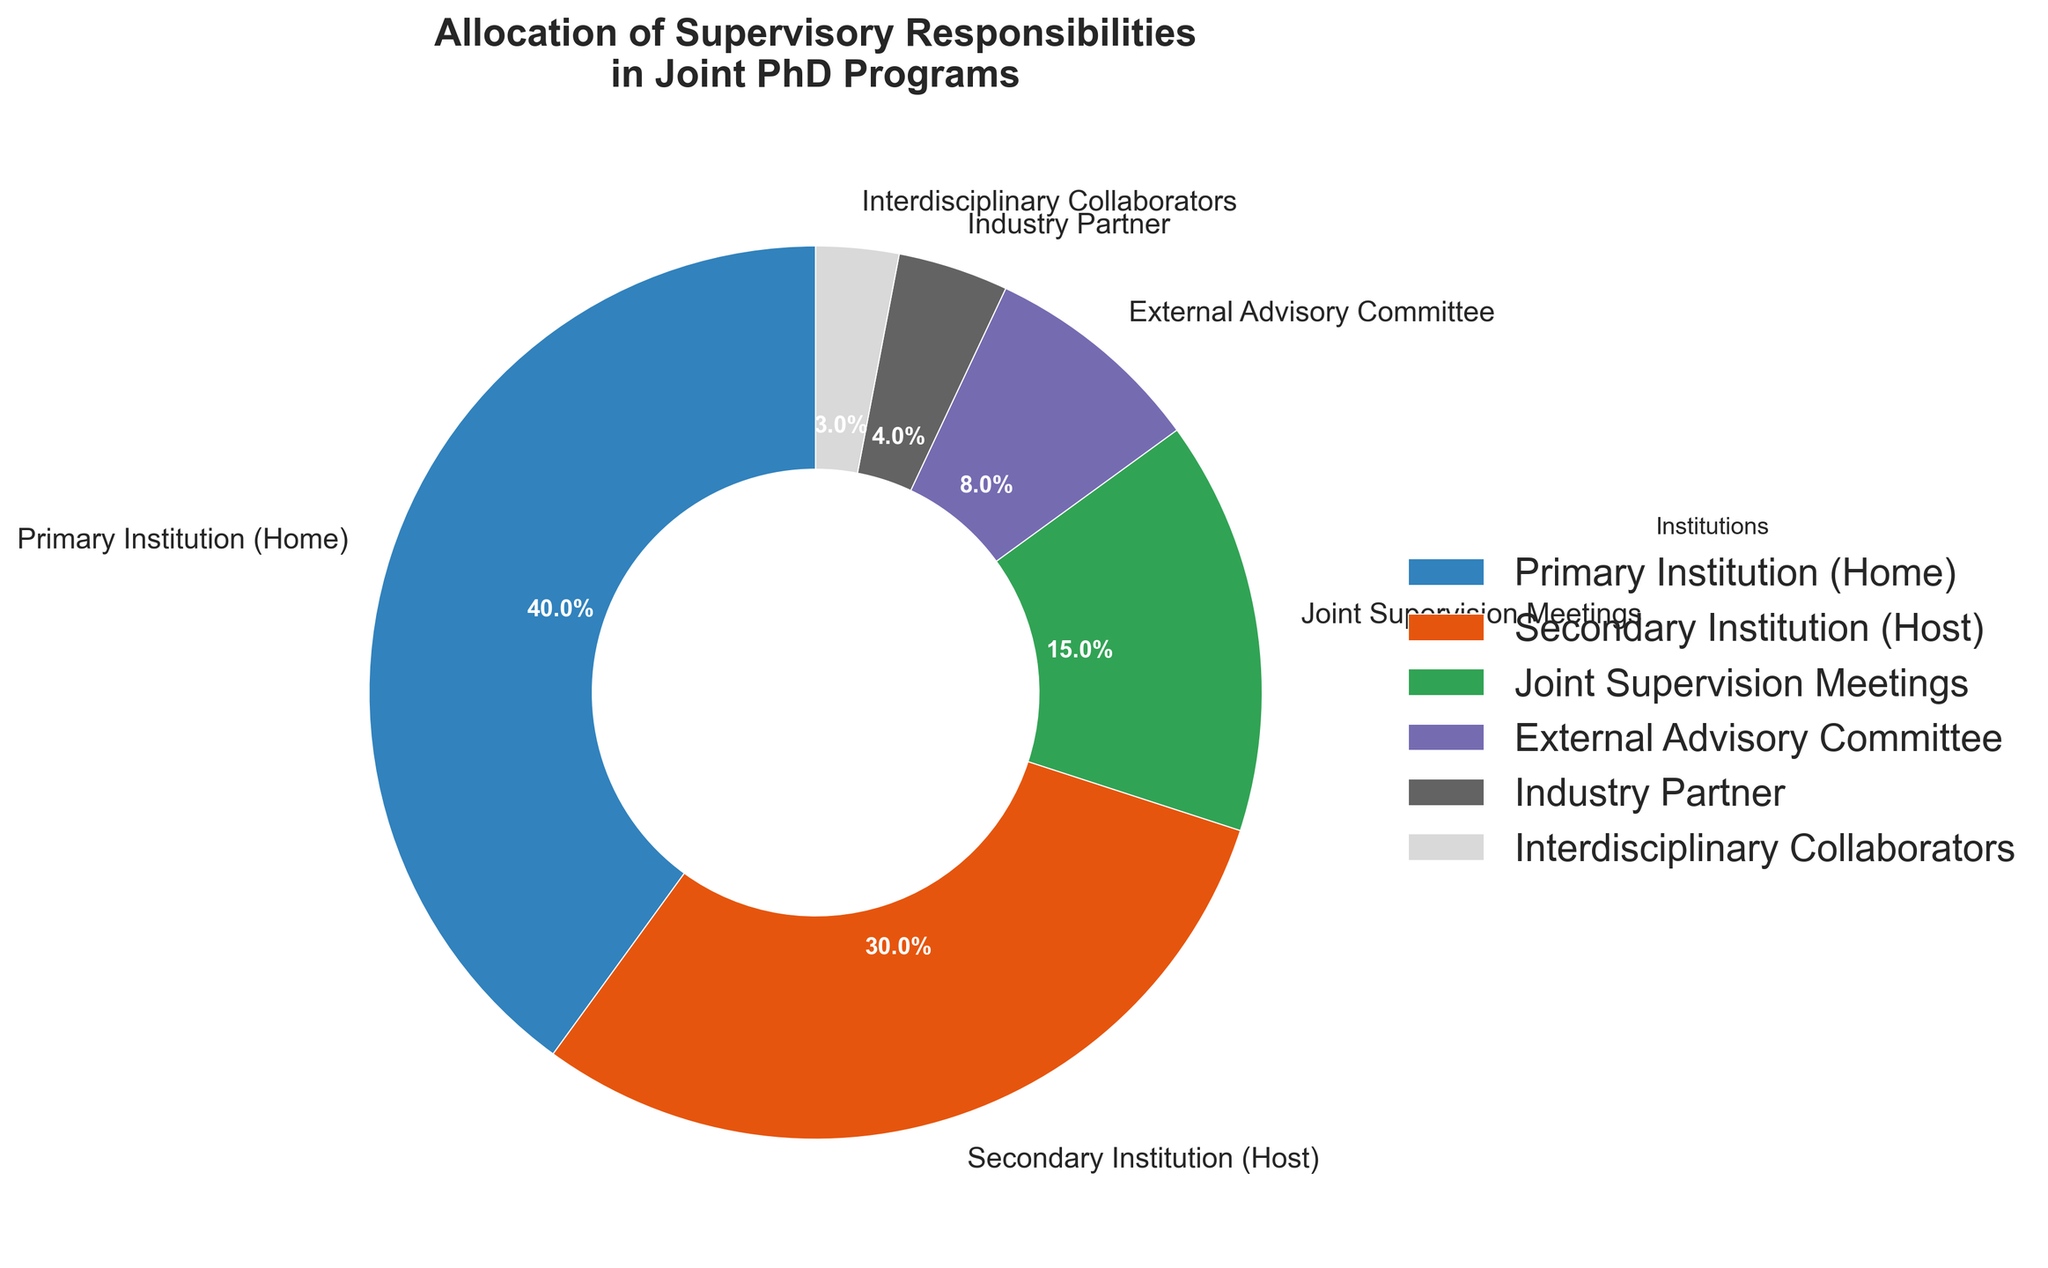What is the total percentage allocated to the Primary Institution (Home) and the Secondary Institution (Host)? Add the percentages for the Primary Institution (Home) and Secondary Institution (Host): 40% + 30% = 70%
Answer: 70% Which institution has the smallest allocation of supervisory responsibilities? Compare the percentages for all institutions: Industry Partner (4%), Interdisciplinary Collaborators (3%), External Advisory Committee (8%), Joint Supervision Meetings (15%), Secondary Institution (Host) (30%), Primary Institution (Home) (40%). The smallest value is 3%
Answer: Interdisciplinary Collaborators What percentage of the allocation is handled by the Primary Institution (Home) compared to the External Advisory Committee? Compare the percentages for both: 40% (Primary Institution Home) is greater than 8% (External Advisory Committee)
Answer: 40% is greater than 8% How much more percentage does the Secondary Institution (Host) have compared to the Industry Partner and Interdisciplinary Collaborators combined? Combined percentage of Industry Partner and Interdisciplinary Collaborators: 4% + 3% = 7%. Difference between Secondary Institution (30%) and this combined percentage: 30% - 7% = 23%
Answer: 23% What is the combined percentage of Joint Supervision Meetings and External Advisory Committee? Add the percentages for Joint Supervision Meetings and External Advisory Committee: 15% + 8% = 23%
Answer: 23% Identify the institutions with allocations above 20%. The institutions with allocations more than 20% are Primary Institution (Home) 40% and Secondary Institution (Host) 30%
Answer: Primary Institution (Home), Secondary Institution (Host) How many institutions have an allocation percentage less than 10%? Identify and count the institutions below 10%: Industry Partner (4%), Interdisciplinary Collaborators (3%), and External Advisory Committee (8%). There are 3 institutions
Answer: 3 What is the average percentage allocation across all institutions? Sum all percentages: 40% (Primary Institution) + 30% (Secondary Institution) + 15% (Joint Supervision Meetings) + 8% (External Advisory Committee) + 4% (Industry Partner) + 3% (Interdisciplinary Collaborators) = 100%. Divide by the number of data points (6): 100% / 6 ≈ 16.67%
Answer: 16.67% 